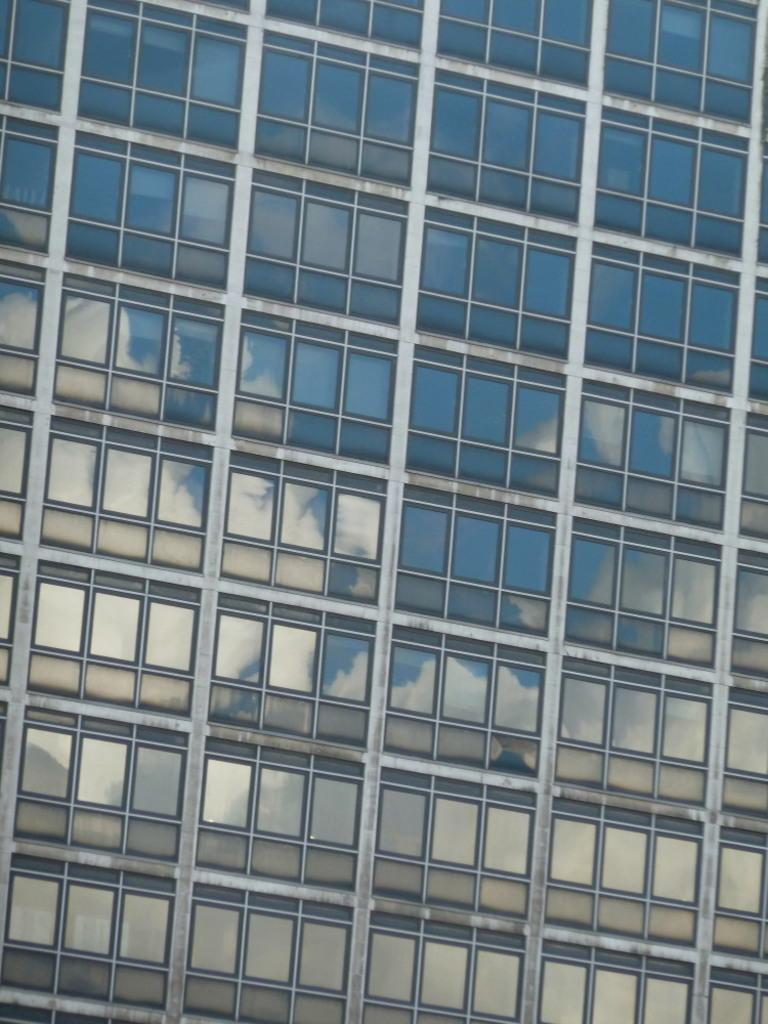What is the main structure visible in the image? There is a building in the image. What feature can be seen on the building? The building has windows. What type of tramp can be seen jumping near the building in the image? There is no tramp present in the image; it only features a building with windows. What type of flesh is visible on the building in the image? There is no flesh visible on the building in the image; it is a structure made of materials like brick, concrete, or glass. 